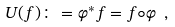Convert formula to latex. <formula><loc_0><loc_0><loc_500><loc_500>U ( f ) \colon = \varphi ^ { * } f = f \circ \varphi \ ,</formula> 